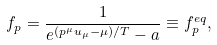Convert formula to latex. <formula><loc_0><loc_0><loc_500><loc_500>f _ { p } = \frac { 1 } { e ^ { ( p ^ { \mu } u _ { \mu } - \mu ) / T } - a } \equiv f ^ { e q } _ { p } ,</formula> 